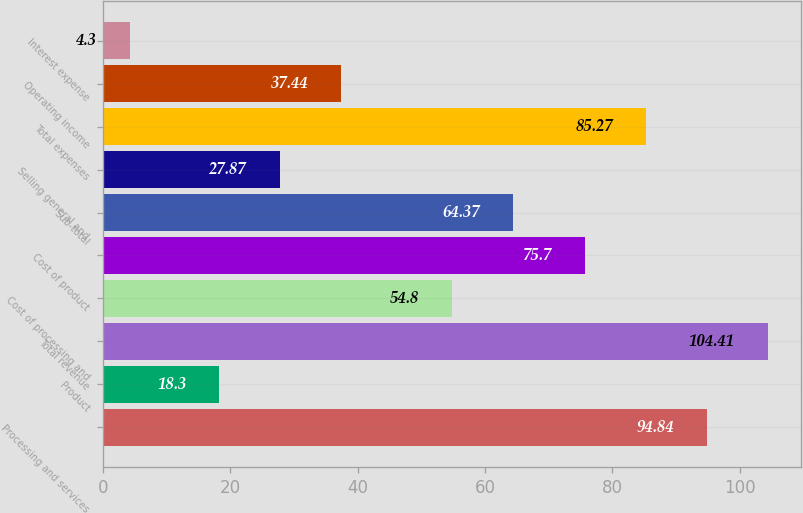Convert chart to OTSL. <chart><loc_0><loc_0><loc_500><loc_500><bar_chart><fcel>Processing and services<fcel>Product<fcel>Total revenue<fcel>Cost of processing and<fcel>Cost of product<fcel>Sub-total<fcel>Selling general and<fcel>Total expenses<fcel>Operating income<fcel>Interest expense<nl><fcel>94.84<fcel>18.3<fcel>104.41<fcel>54.8<fcel>75.7<fcel>64.37<fcel>27.87<fcel>85.27<fcel>37.44<fcel>4.3<nl></chart> 